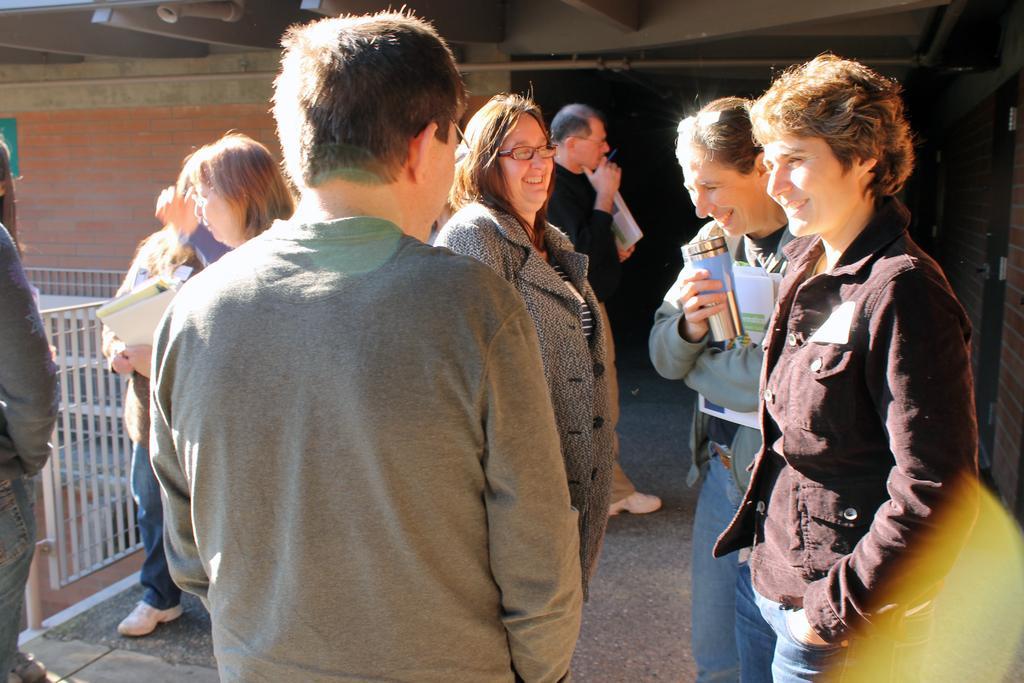Describe this image in one or two sentences. In this image people are standing, in the background there is a wall and entrance and a fencing. 